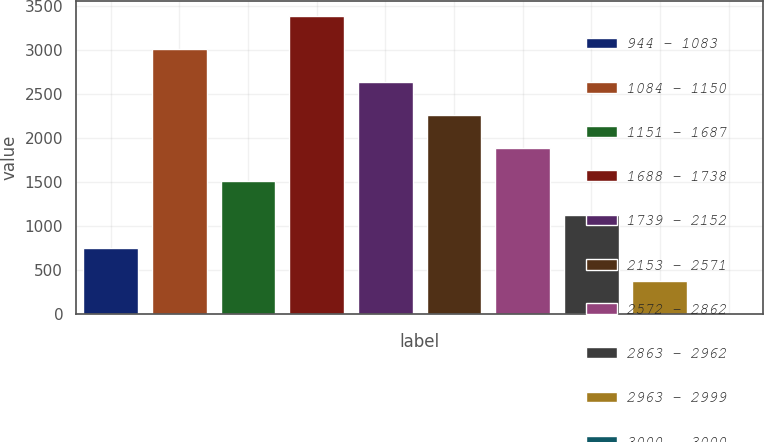Convert chart. <chart><loc_0><loc_0><loc_500><loc_500><bar_chart><fcel>944 - 1083<fcel>1084 - 1150<fcel>1151 - 1687<fcel>1688 - 1738<fcel>1739 - 2152<fcel>2153 - 2571<fcel>2572 - 2862<fcel>2863 - 2962<fcel>2963 - 2999<fcel>3000 - 3000<nl><fcel>754.4<fcel>3008.6<fcel>1505.8<fcel>3384.3<fcel>2632.9<fcel>2257.2<fcel>1881.5<fcel>1130.1<fcel>378.7<fcel>3<nl></chart> 